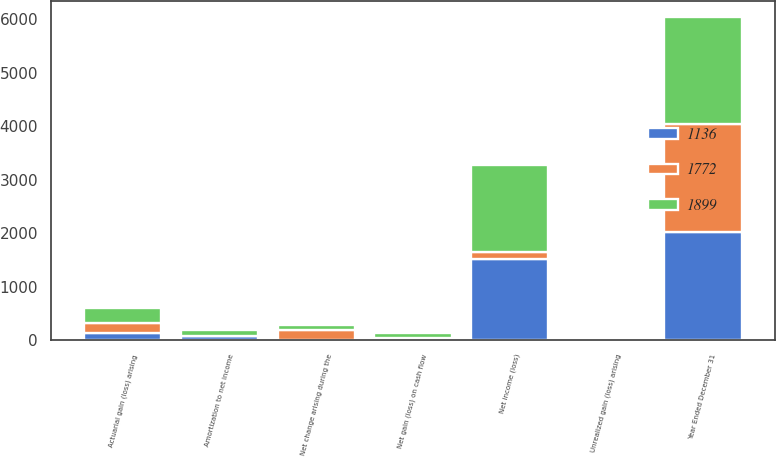Convert chart to OTSL. <chart><loc_0><loc_0><loc_500><loc_500><stacked_bar_chart><ecel><fcel>Year Ended December 31<fcel>Net income (loss)<fcel>Net change arising during the<fcel>Unrealized gain (loss) arising<fcel>Net gain (loss) on cash flow<fcel>Actuarial gain (loss) arising<fcel>Amortization to net income<nl><fcel>1772<fcel>2018<fcel>134<fcel>191<fcel>11<fcel>16<fcel>186<fcel>5<nl><fcel>1136<fcel>2017<fcel>1513<fcel>3<fcel>8<fcel>22<fcel>134<fcel>80<nl><fcel>1899<fcel>2016<fcel>1627<fcel>83<fcel>21<fcel>101<fcel>289<fcel>102<nl></chart> 